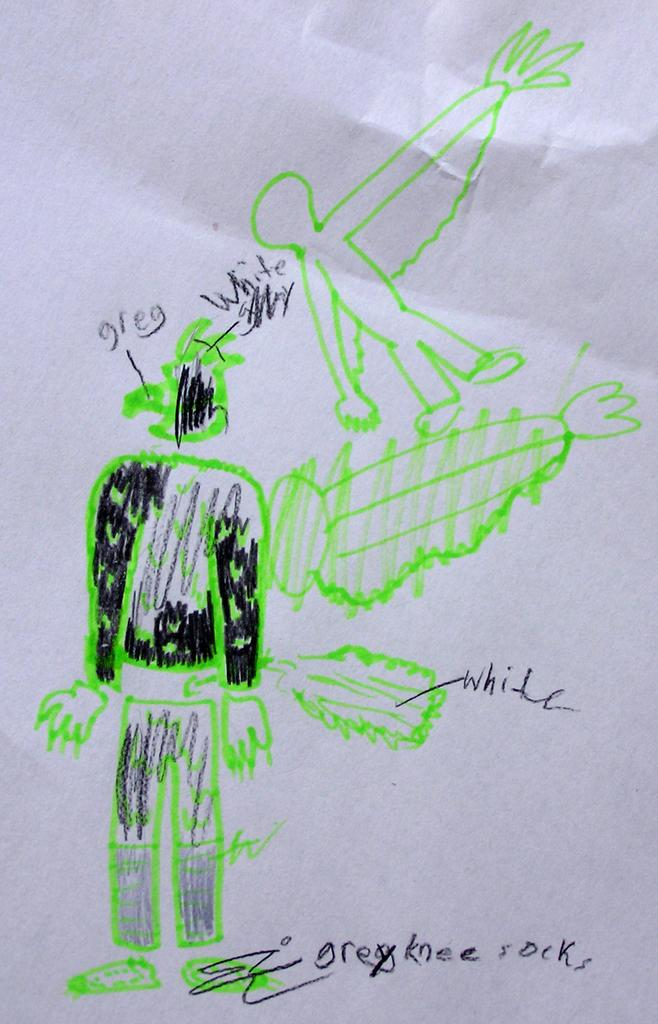What is present on the paper in the image? There is text and a sketch on a paper in the image. Can you describe the text on the paper? Unfortunately, the specific content of the text cannot be determined from the image. What is depicted in the sketch on the paper? The content of the sketch cannot be determined from the image. Is the paper sinking in quicksand in the image? There is no quicksand present in the image, and the paper is not sinking. How many eyes can be seen on the paper in the image? There are no eyes depicted on the paper in the image. 